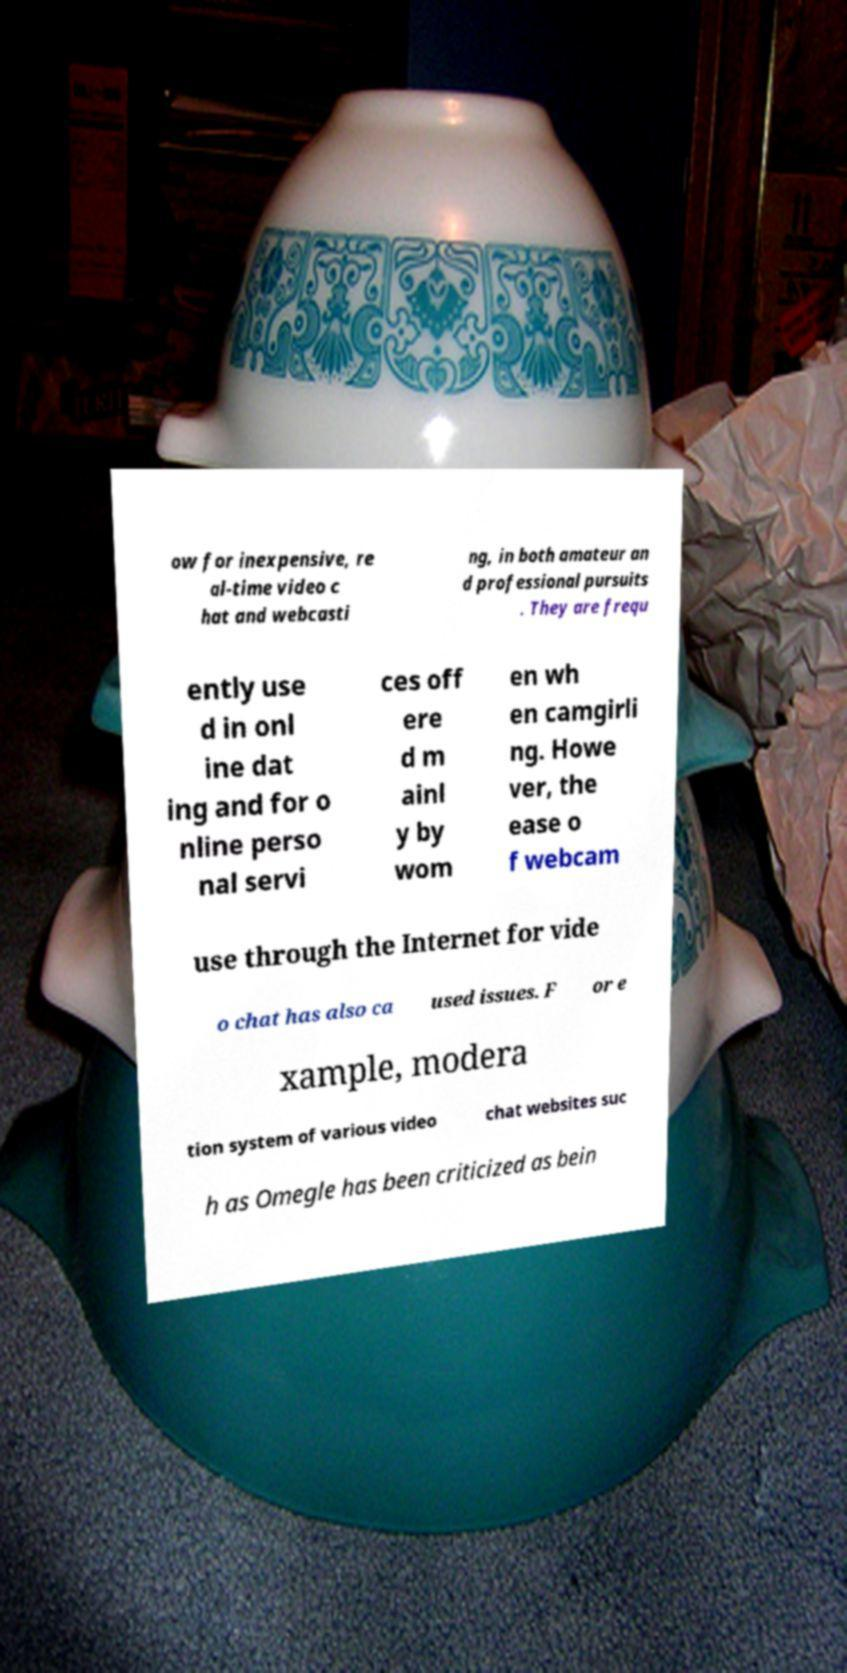Can you read and provide the text displayed in the image?This photo seems to have some interesting text. Can you extract and type it out for me? ow for inexpensive, re al-time video c hat and webcasti ng, in both amateur an d professional pursuits . They are frequ ently use d in onl ine dat ing and for o nline perso nal servi ces off ere d m ainl y by wom en wh en camgirli ng. Howe ver, the ease o f webcam use through the Internet for vide o chat has also ca used issues. F or e xample, modera tion system of various video chat websites suc h as Omegle has been criticized as bein 